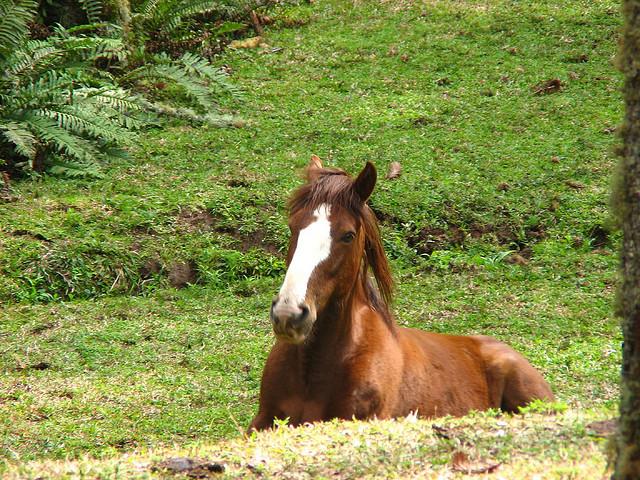Is the horse standing?
Quick response, please. No. How many horses are there?
Give a very brief answer. 1. Is this horse one solid color?
Be succinct. No. 